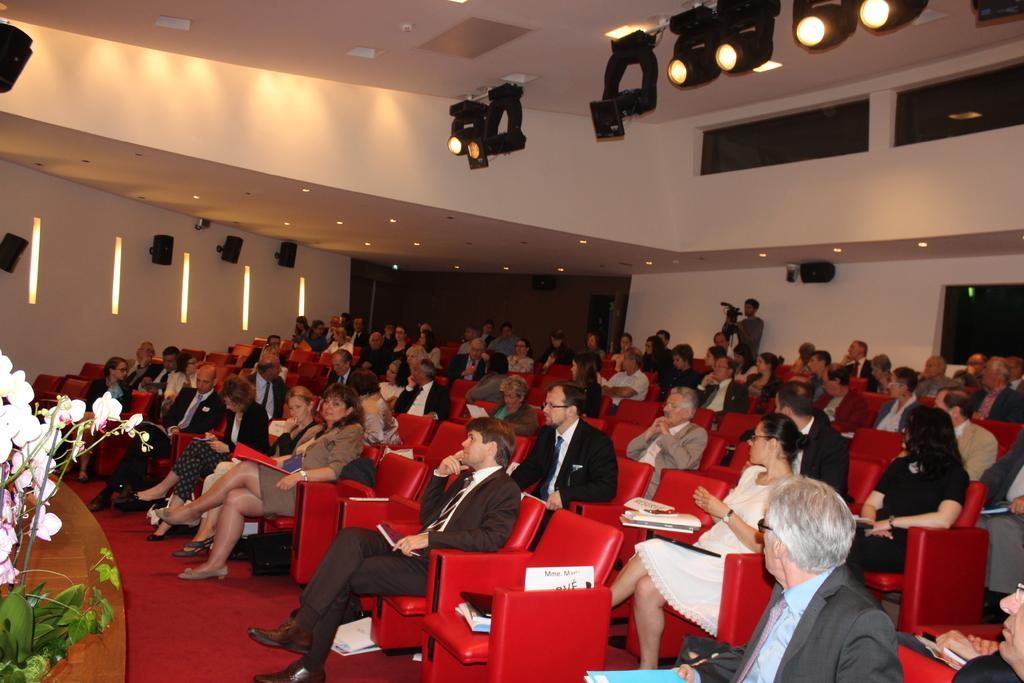Describe this image in one or two sentences. In this image, there are groups of people sitting in the chairs. These chairs are red in color. Here is a person standing. These are the speakers, which are attached to a wall. I can see the ceiling lights and the focus lights, which are attached to the ceiling. I think these are the files and books. On the left side of the image, that looks like a plant with the flowers. I think this is the floor. 